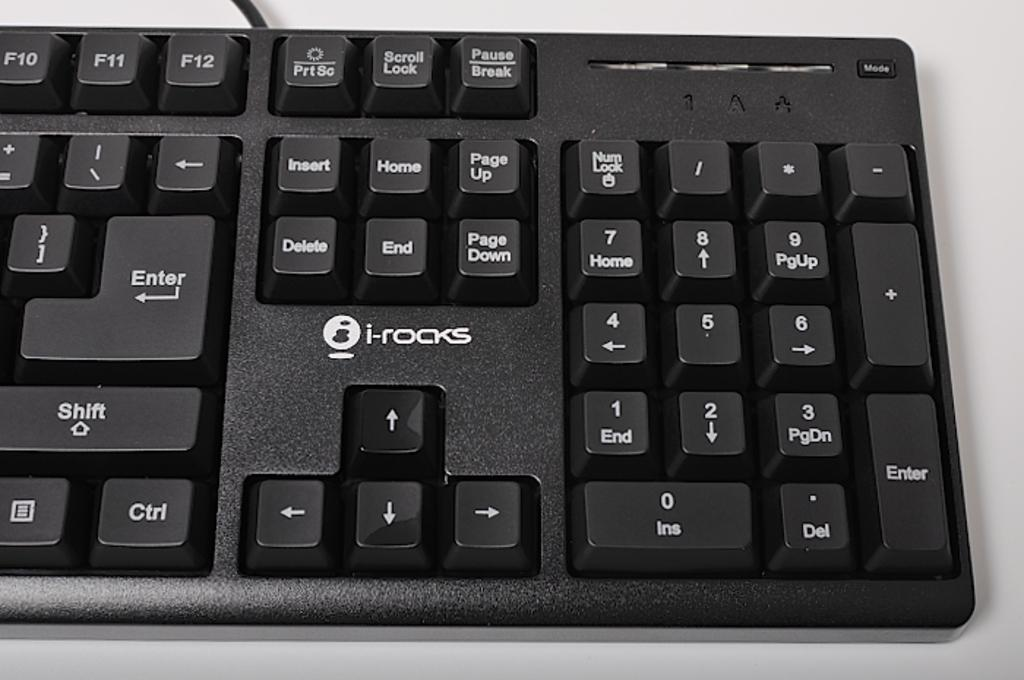Provide a one-sentence caption for the provided image. An i-rocks keyboard with keys like Insert and Home displayed. 